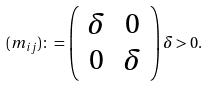Convert formula to latex. <formula><loc_0><loc_0><loc_500><loc_500>( m _ { i j } ) \colon = \left ( \begin{array} { c c } \delta & 0 \\ 0 & \delta \\ \end{array} \right ) \delta > 0 .</formula> 